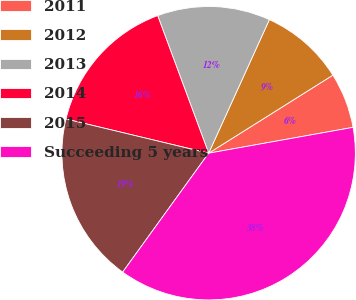Convert chart. <chart><loc_0><loc_0><loc_500><loc_500><pie_chart><fcel>2011<fcel>2012<fcel>2013<fcel>2014<fcel>2015<fcel>Succeeding 5 years<nl><fcel>6.11%<fcel>9.28%<fcel>12.44%<fcel>15.61%<fcel>18.78%<fcel>37.78%<nl></chart> 